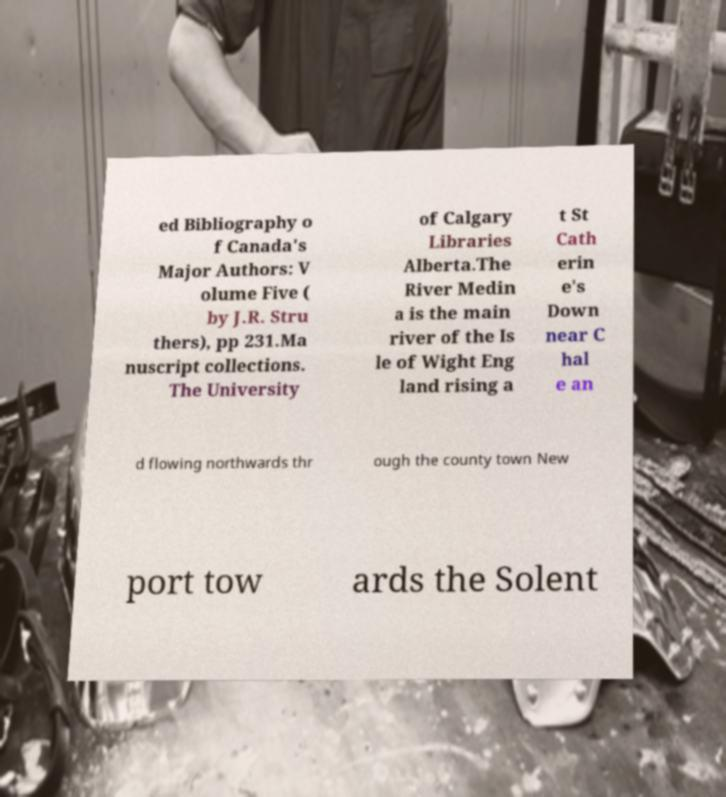Could you assist in decoding the text presented in this image and type it out clearly? ed Bibliography o f Canada's Major Authors: V olume Five ( by J.R. Stru thers), pp 231.Ma nuscript collections. The University of Calgary Libraries Alberta.The River Medin a is the main river of the Is le of Wight Eng land rising a t St Cath erin e's Down near C hal e an d flowing northwards thr ough the county town New port tow ards the Solent 